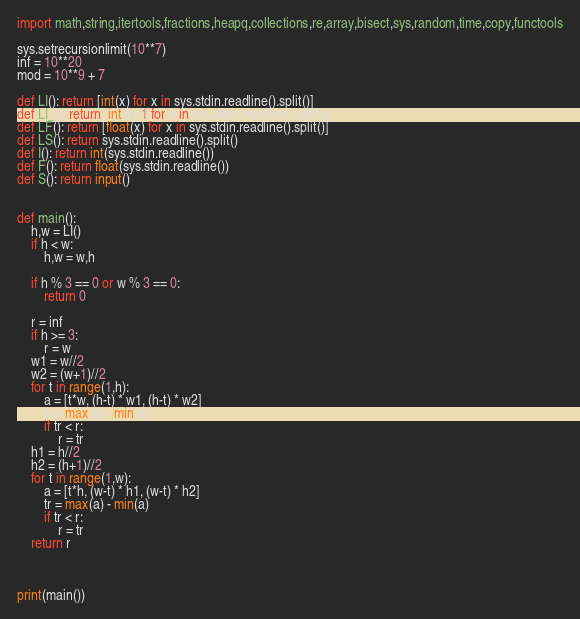Convert code to text. <code><loc_0><loc_0><loc_500><loc_500><_Python_>import math,string,itertools,fractions,heapq,collections,re,array,bisect,sys,random,time,copy,functools

sys.setrecursionlimit(10**7)
inf = 10**20
mod = 10**9 + 7

def LI(): return [int(x) for x in sys.stdin.readline().split()]
def LI_(): return [int(x)-1 for x in sys.stdin.readline().split()]
def LF(): return [float(x) for x in sys.stdin.readline().split()]
def LS(): return sys.stdin.readline().split()
def I(): return int(sys.stdin.readline())
def F(): return float(sys.stdin.readline())
def S(): return input()


def main():
    h,w = LI()
    if h < w:
        h,w = w,h

    if h % 3 == 0 or w % 3 == 0:
        return 0

    r = inf
    if h >= 3:
        r = w
    w1 = w//2
    w2 = (w+1)//2
    for t in range(1,h):
        a = [t*w, (h-t) * w1, (h-t) * w2]
        tr = max(a) - min(a)
        if tr < r:
            r = tr
    h1 = h//2
    h2 = (h+1)//2
    for t in range(1,w):
        a = [t*h, (w-t) * h1, (w-t) * h2]
        tr = max(a) - min(a)
        if tr < r:
            r = tr
    return r



print(main())
</code> 